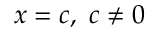<formula> <loc_0><loc_0><loc_500><loc_500>x = c , \ c \neq 0</formula> 